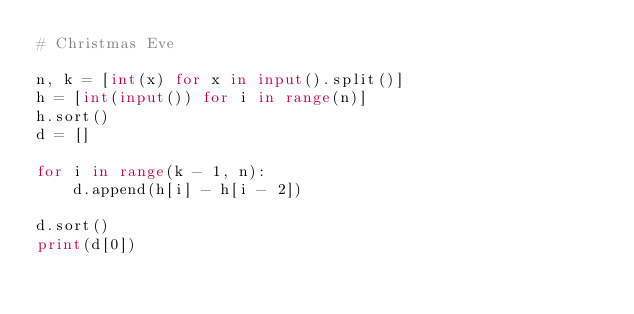Convert code to text. <code><loc_0><loc_0><loc_500><loc_500><_Python_># Christmas Eve

n, k = [int(x) for x in input().split()]
h = [int(input()) for i in range(n)]
h.sort()
d = []

for i in range(k - 1, n):
    d.append(h[i] - h[i - 2])

d.sort()
print(d[0])
</code> 